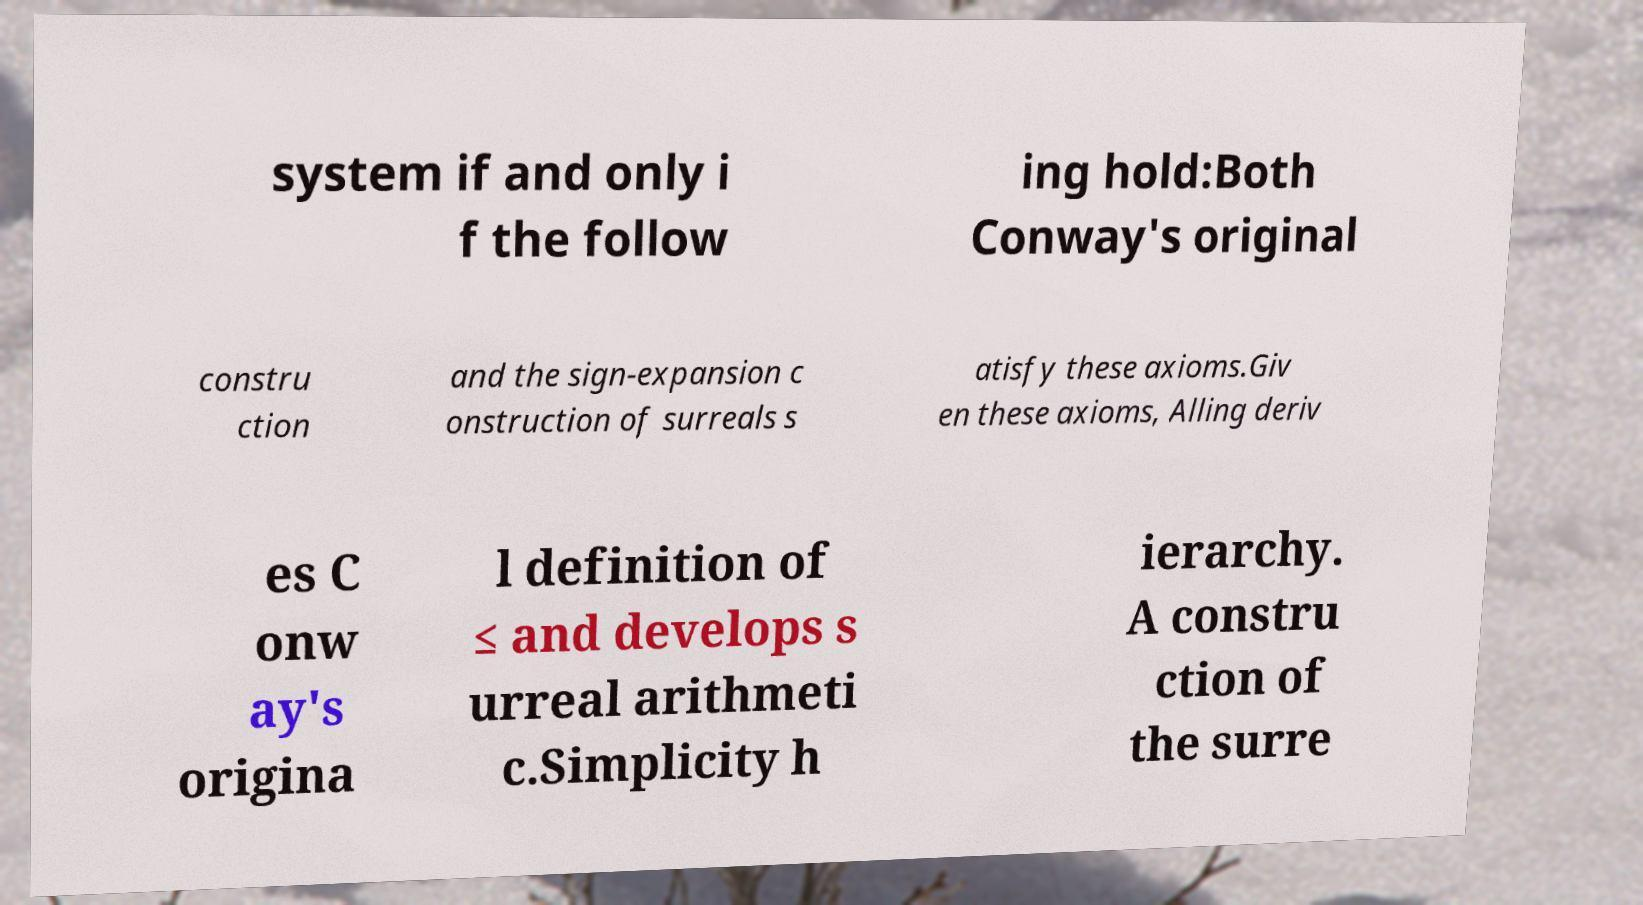Can you accurately transcribe the text from the provided image for me? system if and only i f the follow ing hold:Both Conway's original constru ction and the sign-expansion c onstruction of surreals s atisfy these axioms.Giv en these axioms, Alling deriv es C onw ay's origina l definition of ≤ and develops s urreal arithmeti c.Simplicity h ierarchy. A constru ction of the surre 